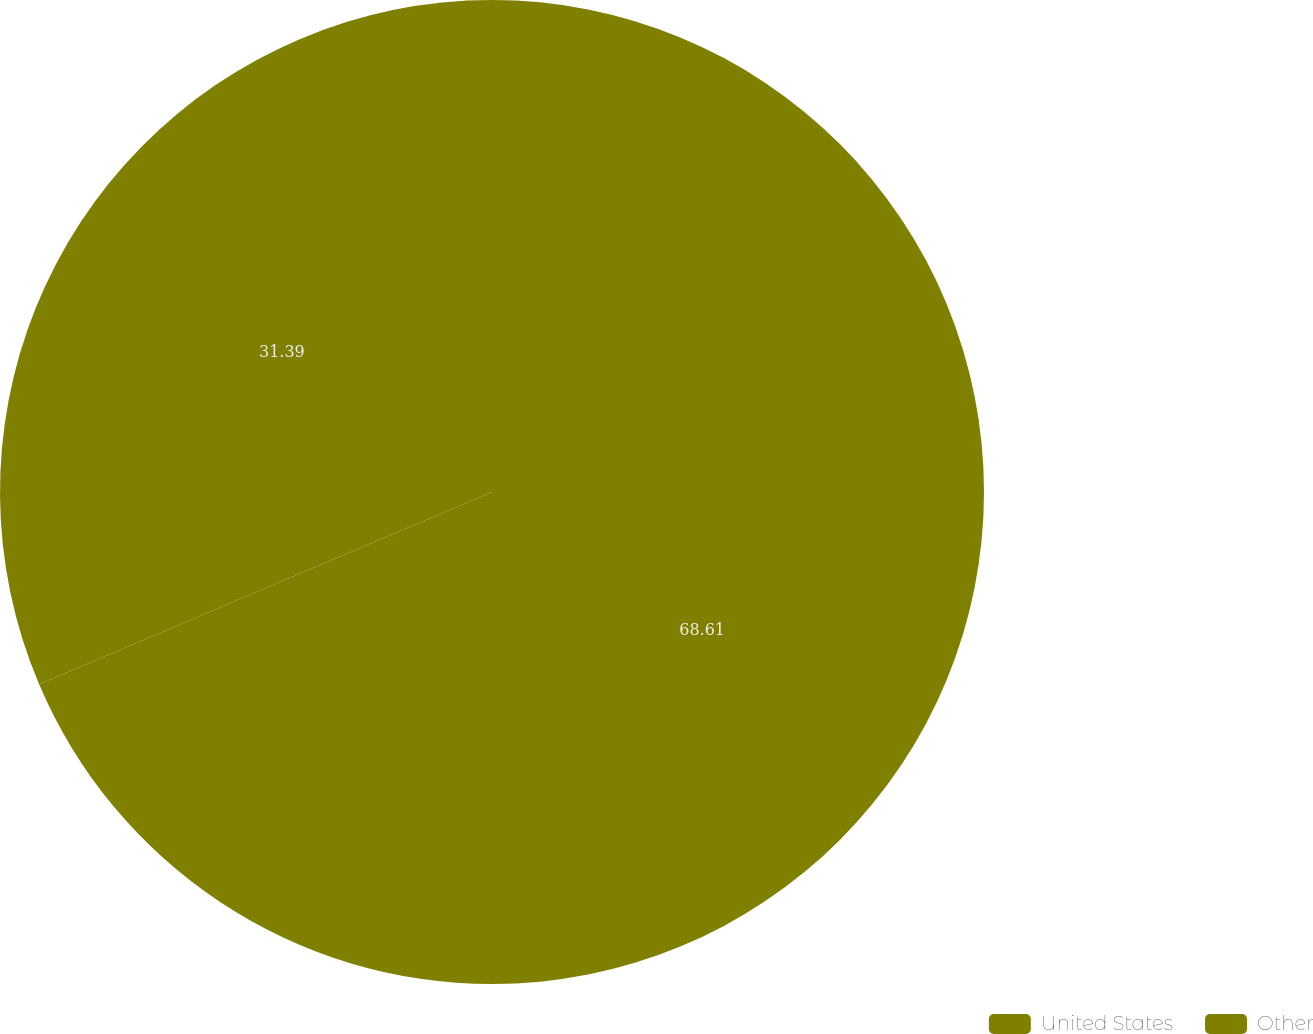<chart> <loc_0><loc_0><loc_500><loc_500><pie_chart><fcel>United States<fcel>Other<nl><fcel>68.61%<fcel>31.39%<nl></chart> 